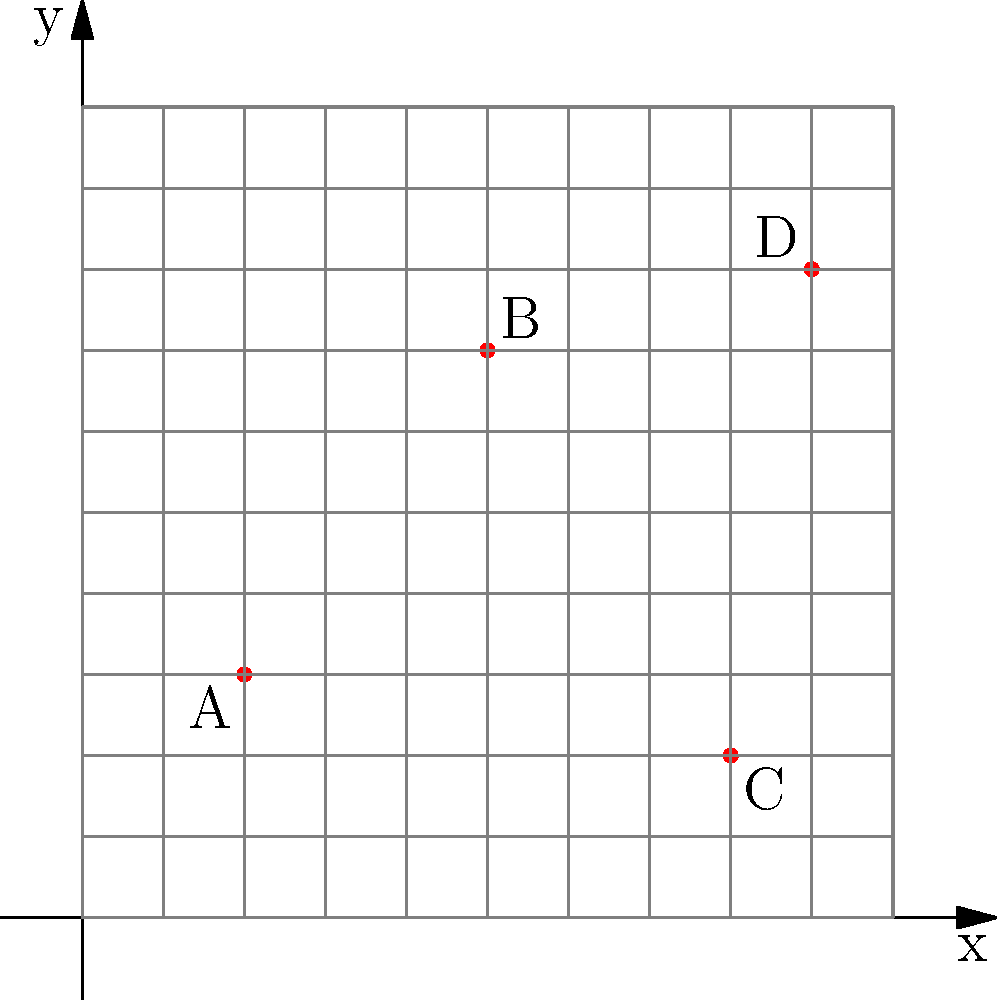On a city map represented by a coordinate system, four of your favorite comic book stores are marked as points A, B, C, and D. If you're currently at point (4, 4) on the map, which store is closest to your location? To determine which comic book store is closest to your current location at (4, 4), we need to calculate the distance between your position and each store using the distance formula:

$d = \sqrt{(x_2 - x_1)^2 + (y_2 - y_1)^2}$

Let's calculate the distance to each store:

1. Store A (2, 3):
   $d_A = \sqrt{(2 - 4)^2 + (3 - 4)^2} = \sqrt{4 + 1} = \sqrt{5} \approx 2.24$

2. Store B (5, 7):
   $d_B = \sqrt{(5 - 4)^2 + (7 - 4)^2} = \sqrt{1 + 9} = \sqrt{10} \approx 3.16$

3. Store C (8, 2):
   $d_C = \sqrt{(8 - 4)^2 + (2 - 4)^2} = \sqrt{16 + 4} = \sqrt{20} \approx 4.47$

4. Store D (9, 8):
   $d_D = \sqrt{(9 - 4)^2 + (8 - 4)^2} = \sqrt{25 + 16} = \sqrt{41} \approx 6.40$

The shortest distance is approximately 2.24, which corresponds to Store A.
Answer: Store A 